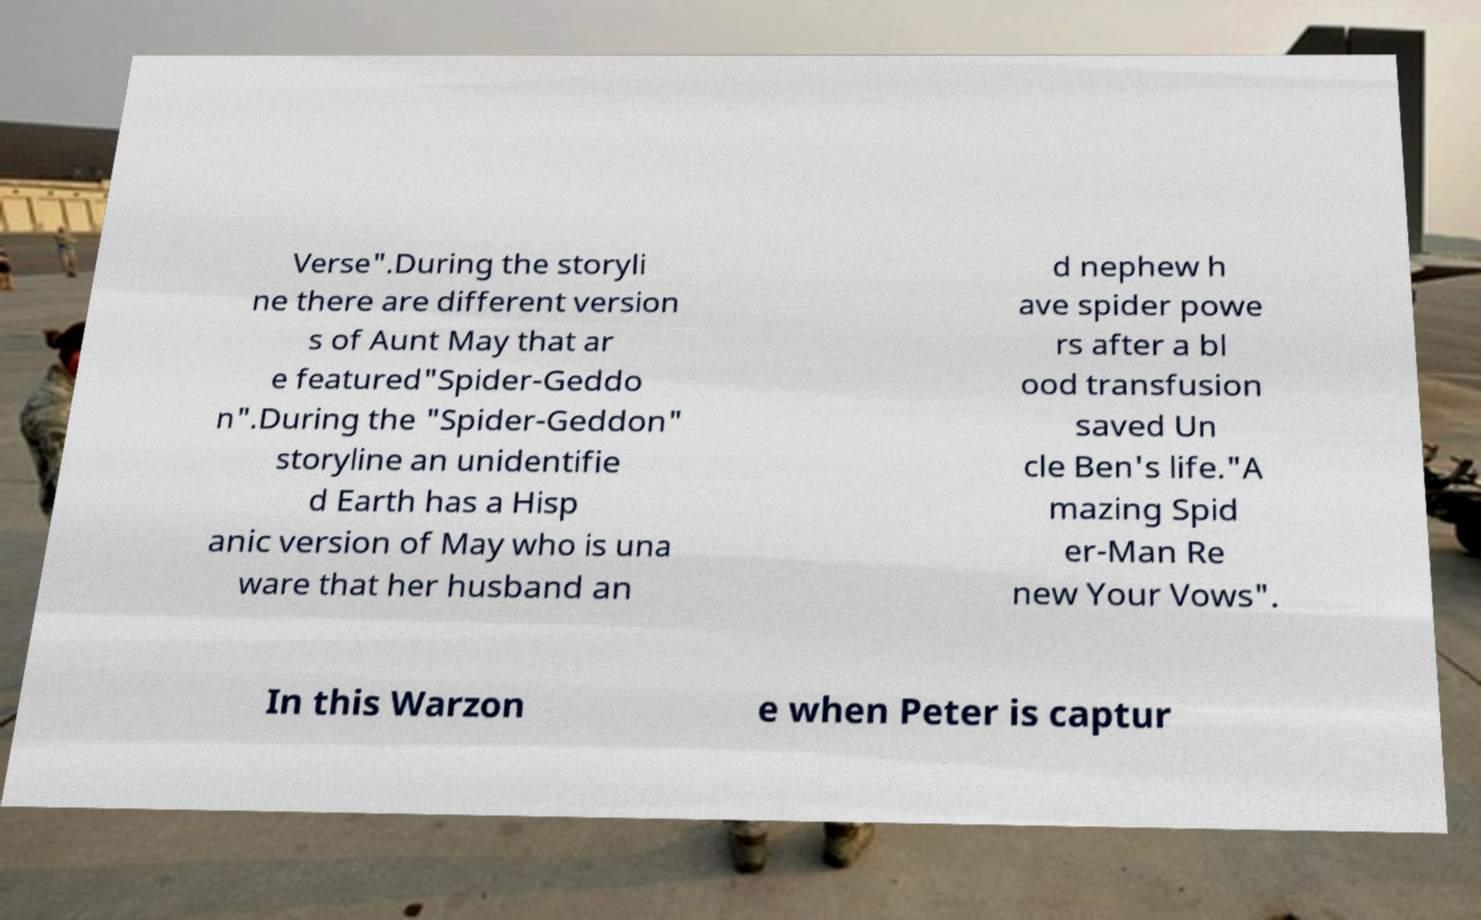For documentation purposes, I need the text within this image transcribed. Could you provide that? Verse".During the storyli ne there are different version s of Aunt May that ar e featured"Spider-Geddo n".During the "Spider-Geddon" storyline an unidentifie d Earth has a Hisp anic version of May who is una ware that her husband an d nephew h ave spider powe rs after a bl ood transfusion saved Un cle Ben's life."A mazing Spid er-Man Re new Your Vows". In this Warzon e when Peter is captur 